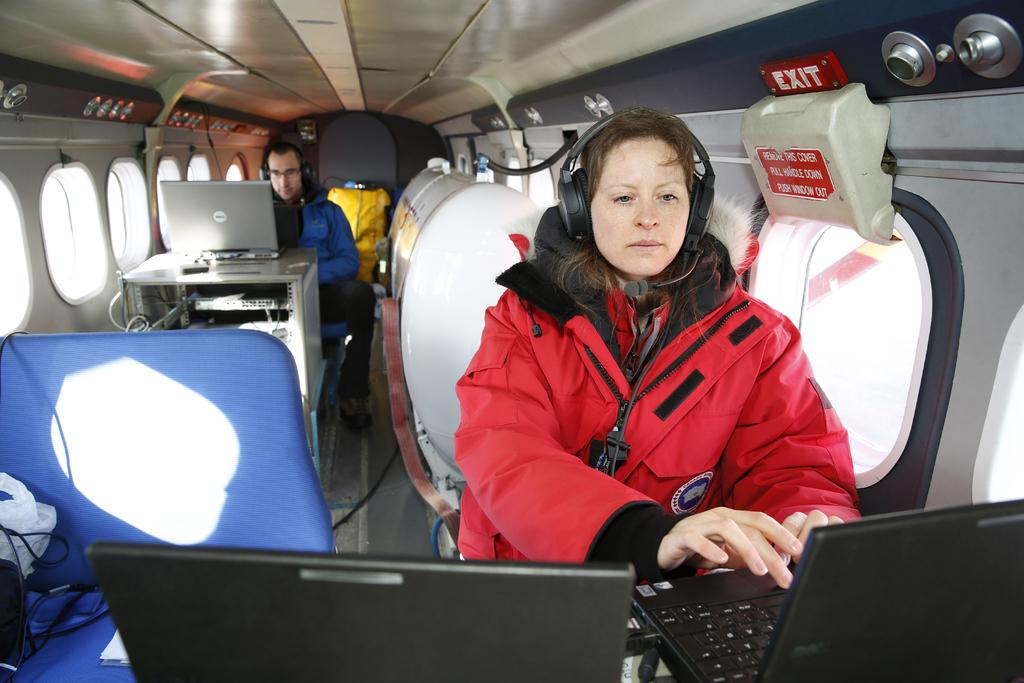How many people are present in the image? There are two people in the image, a woman and a man. What are the people in the image doing? They are both seated and working on laptops. Where are the people in the image located? They are seated in a plane. What are they wearing on their heads? They are both wearing headsets. How many laptops can be seen in the image? There are at least two laptops visible in the image. What type of tomatoes are being used in the competition in the image? There is no competition or tomatoes present in the image. Is the woman wearing a scarf in the image? The image does not show the woman wearing a scarf. 